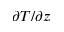Convert formula to latex. <formula><loc_0><loc_0><loc_500><loc_500>\partial T / \partial z</formula> 